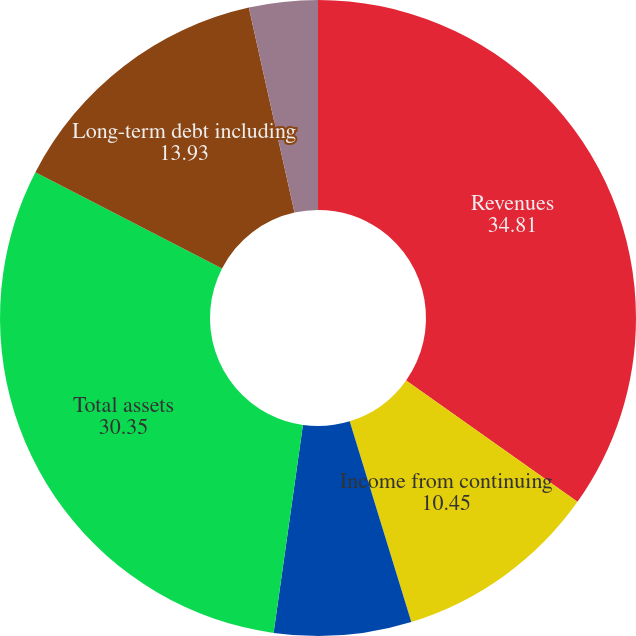<chart> <loc_0><loc_0><loc_500><loc_500><pie_chart><fcel>Revenues<fcel>Income from continuing<fcel>Net income<fcel>Total assets<fcel>Long-term debt including<fcel>Basic earnings per share -<nl><fcel>34.81%<fcel>10.45%<fcel>6.97%<fcel>30.35%<fcel>13.93%<fcel>3.49%<nl></chart> 